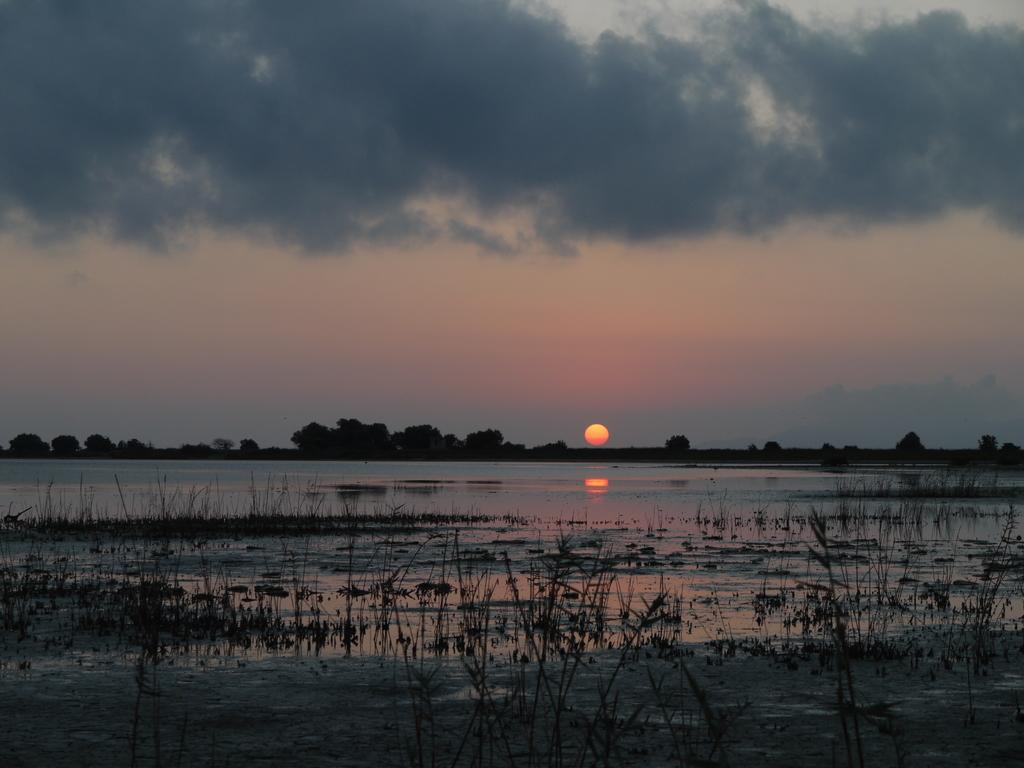What is visible in the image? Water is visible in the image. What can be seen in the background of the image? There are trees in the background of the image. What celestial body is visible in the image? The sun is visible in the image. How would you describe the appearance of the sun in the image? The sun has orange and yellow colors. What colors are present in the sky in the image? The sky has white and gray colors. How much money is being exchanged in the image? There is no exchange of money depicted in the image. What season is represented by the falling land in the image? There is no falling land or indication of a season in the image. 